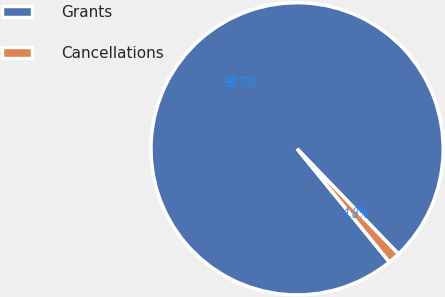Convert chart. <chart><loc_0><loc_0><loc_500><loc_500><pie_chart><fcel>Grants<fcel>Cancellations<nl><fcel>98.68%<fcel>1.32%<nl></chart> 